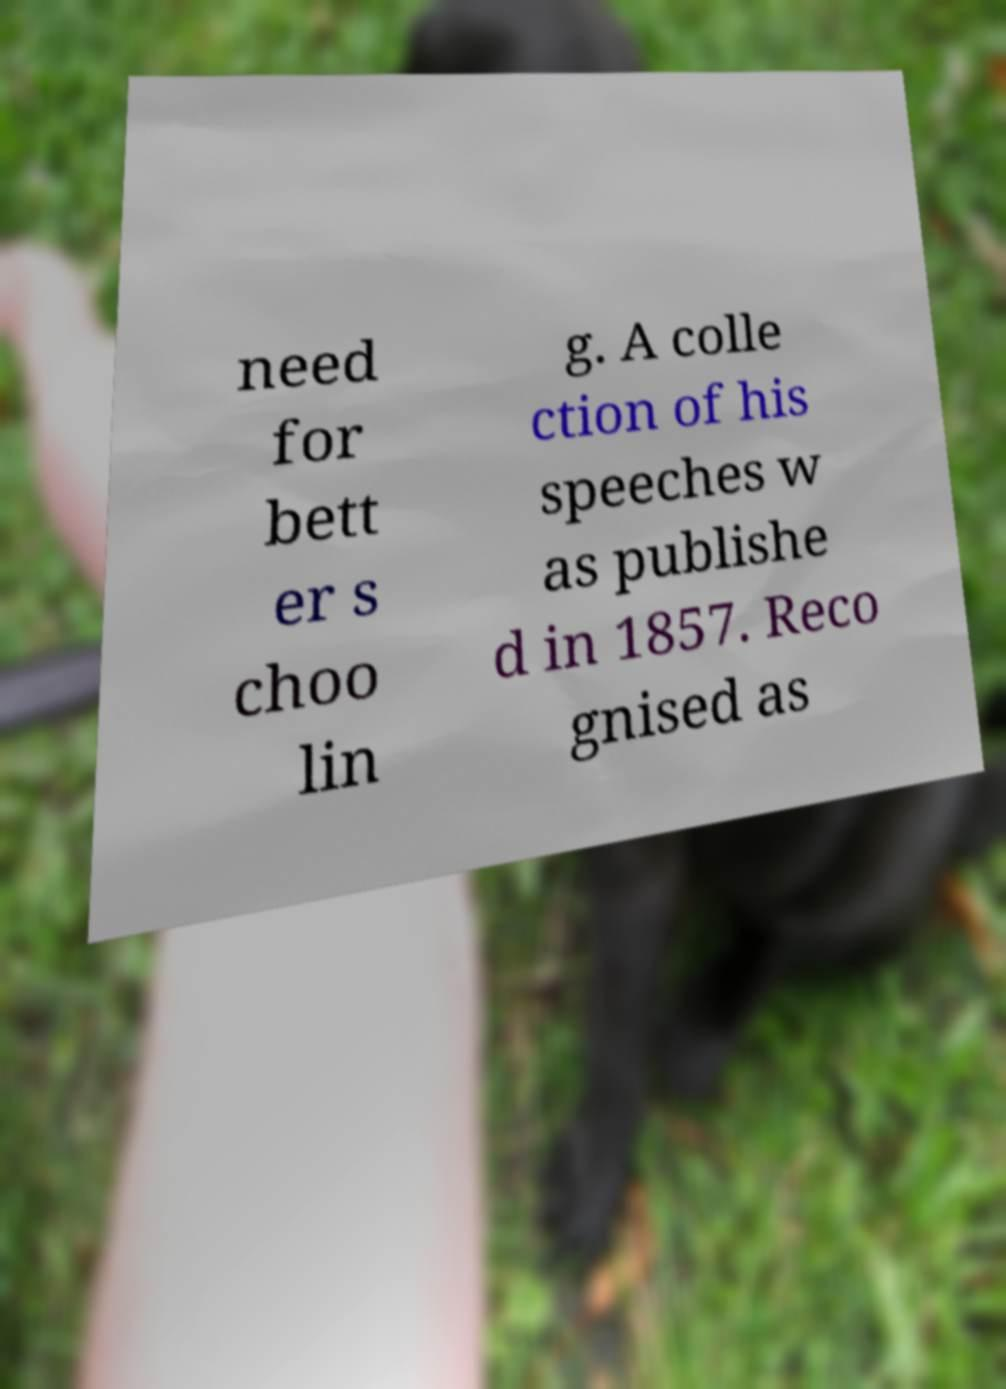There's text embedded in this image that I need extracted. Can you transcribe it verbatim? need for bett er s choo lin g. A colle ction of his speeches w as publishe d in 1857. Reco gnised as 